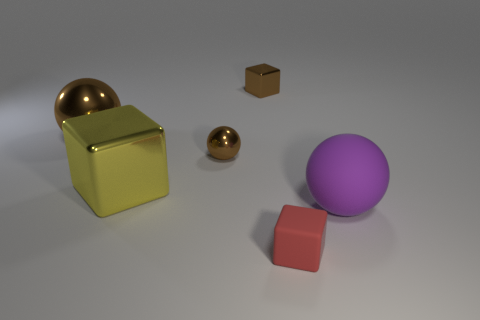Add 2 small metal balls. How many objects exist? 8 Add 6 tiny metal spheres. How many tiny metal spheres exist? 7 Subtract 0 green spheres. How many objects are left? 6 Subtract all small brown blocks. Subtract all yellow metal blocks. How many objects are left? 4 Add 1 big yellow things. How many big yellow things are left? 2 